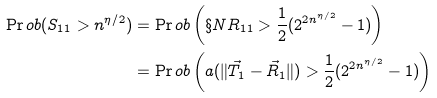Convert formula to latex. <formula><loc_0><loc_0><loc_500><loc_500>\Pr o b ( S _ { 1 1 } > n ^ { \eta / 2 } ) & = \Pr o b \left ( \S N R _ { 1 1 } > \frac { 1 } { 2 } ( 2 ^ { 2 n ^ { \eta / 2 } } - 1 ) \right ) \\ & = \Pr o b \left ( a ( \| \vec { T } _ { 1 } - \vec { R } _ { 1 } \| ) > \frac { 1 } { 2 } ( 2 ^ { 2 n ^ { \eta / 2 } } - 1 ) \right )</formula> 